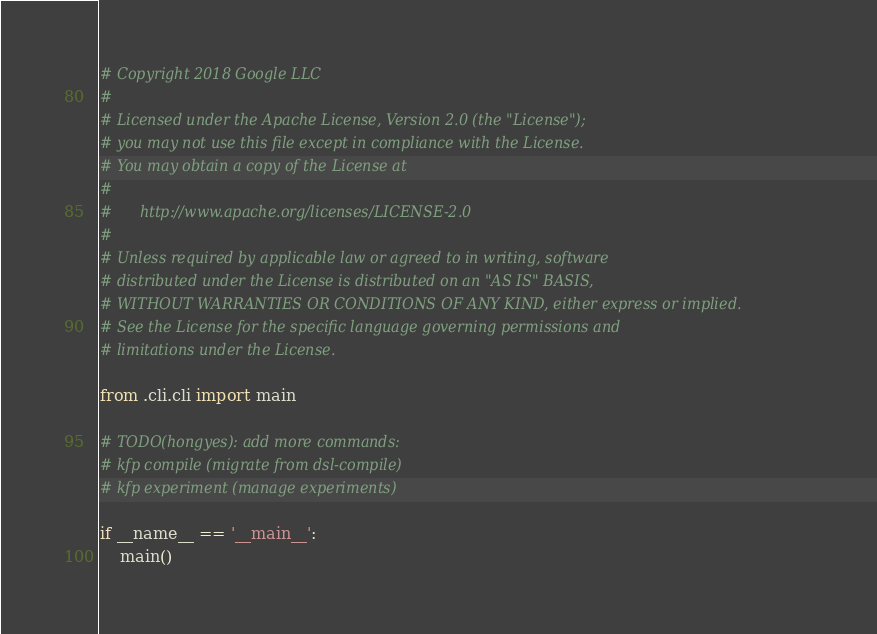Convert code to text. <code><loc_0><loc_0><loc_500><loc_500><_Python_># Copyright 2018 Google LLC
#
# Licensed under the Apache License, Version 2.0 (the "License");
# you may not use this file except in compliance with the License.
# You may obtain a copy of the License at
#
#      http://www.apache.org/licenses/LICENSE-2.0
#
# Unless required by applicable law or agreed to in writing, software
# distributed under the License is distributed on an "AS IS" BASIS,
# WITHOUT WARRANTIES OR CONDITIONS OF ANY KIND, either express or implied.
# See the License for the specific language governing permissions and
# limitations under the License.

from .cli.cli import main

# TODO(hongyes): add more commands:
# kfp compile (migrate from dsl-compile)
# kfp experiment (manage experiments)

if __name__ == '__main__':
    main()
</code> 